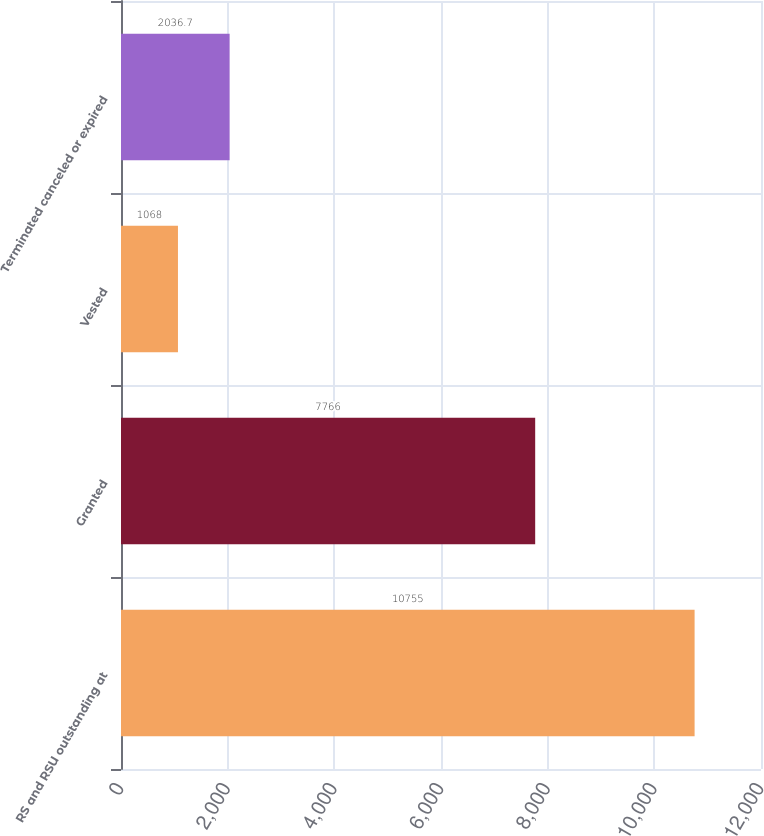<chart> <loc_0><loc_0><loc_500><loc_500><bar_chart><fcel>RS and RSU outstanding at<fcel>Granted<fcel>Vested<fcel>Terminated canceled or expired<nl><fcel>10755<fcel>7766<fcel>1068<fcel>2036.7<nl></chart> 